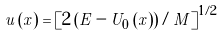Convert formula to latex. <formula><loc_0><loc_0><loc_500><loc_500>u \left ( x \right ) = \left [ 2 \left ( E - U _ { 0 } \left ( x \right ) \right ) / M \right ] ^ { 1 / 2 }</formula> 